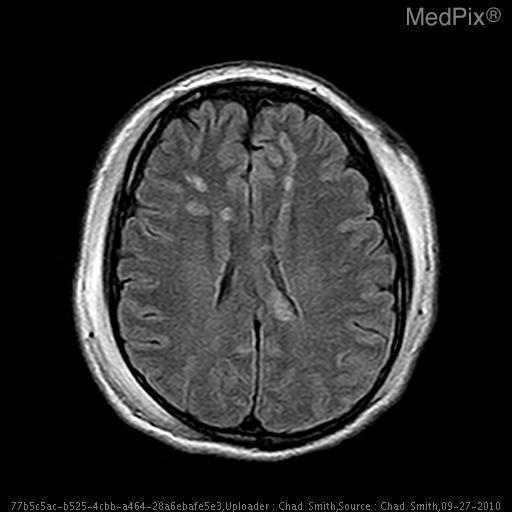What are the locations of the hyperintensities?
Keep it brief. Bilateral frontal lobes and body of corpus callosum. Where are the hyperintensities located?
Be succinct. Bilateral frontal lobes and body of corpus callosum. The imaging modality is...?
Keep it brief. Mri/flair. What is the image modality?
Keep it brief. Mri/flair. What do the hyperintensities likely represent?
Short answer required. Hemorrhage. What are the hyperintensities signaling?
Be succinct. Hemorrhage. Is this process bilateral?
Short answer required. Yes. 